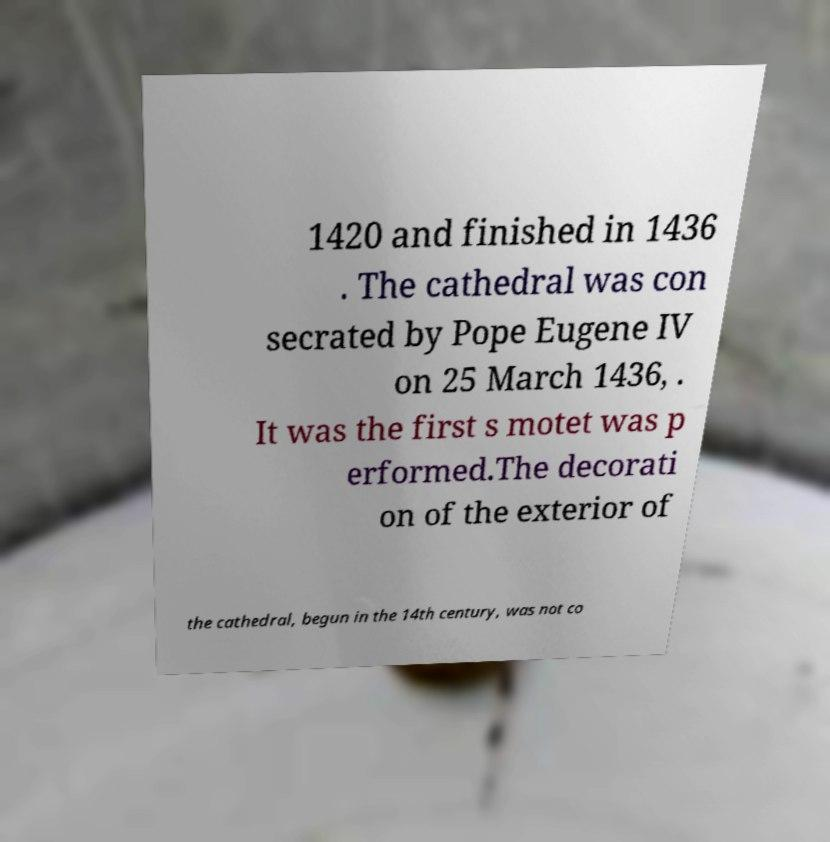Can you accurately transcribe the text from the provided image for me? 1420 and finished in 1436 . The cathedral was con secrated by Pope Eugene IV on 25 March 1436, . It was the first s motet was p erformed.The decorati on of the exterior of the cathedral, begun in the 14th century, was not co 